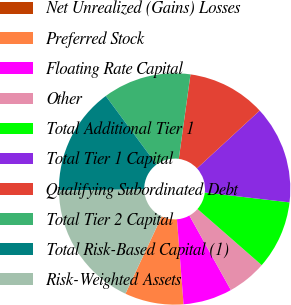<chart> <loc_0><loc_0><loc_500><loc_500><pie_chart><fcel>Net Unrealized (Gains) Losses<fcel>Preferred Stock<fcel>Floating Rate Capital<fcel>Other<fcel>Total Additional Tier 1<fcel>Total Tier 1 Capital<fcel>Qualifying Subordinated Debt<fcel>Total Tier 2 Capital<fcel>Total Risk-Based Capital (1)<fcel>Risk-Weighted Assets<nl><fcel>0.0%<fcel>8.22%<fcel>6.85%<fcel>5.48%<fcel>9.59%<fcel>13.7%<fcel>10.96%<fcel>12.33%<fcel>15.07%<fcel>17.81%<nl></chart> 